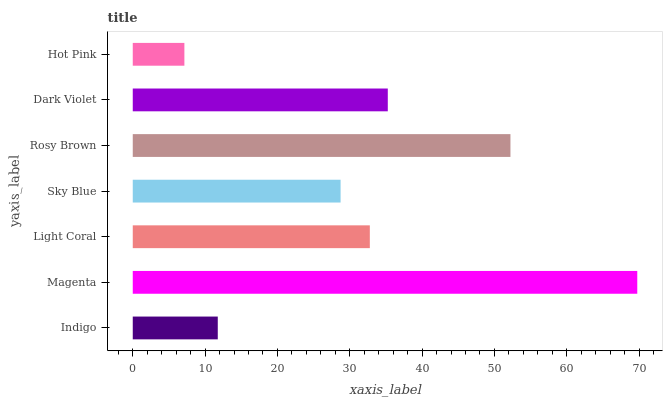Is Hot Pink the minimum?
Answer yes or no. Yes. Is Magenta the maximum?
Answer yes or no. Yes. Is Light Coral the minimum?
Answer yes or no. No. Is Light Coral the maximum?
Answer yes or no. No. Is Magenta greater than Light Coral?
Answer yes or no. Yes. Is Light Coral less than Magenta?
Answer yes or no. Yes. Is Light Coral greater than Magenta?
Answer yes or no. No. Is Magenta less than Light Coral?
Answer yes or no. No. Is Light Coral the high median?
Answer yes or no. Yes. Is Light Coral the low median?
Answer yes or no. Yes. Is Indigo the high median?
Answer yes or no. No. Is Sky Blue the low median?
Answer yes or no. No. 